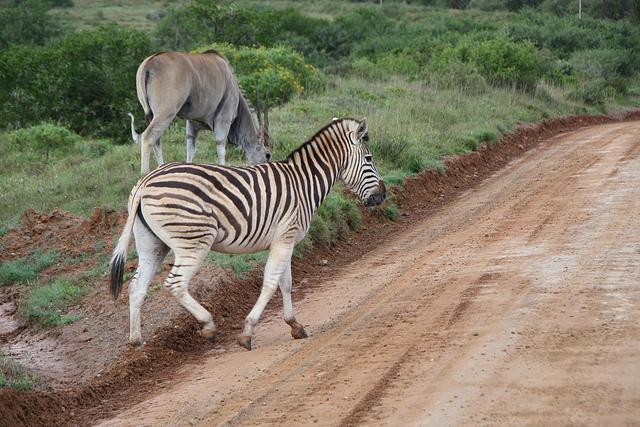What is the zebra on the left about to step into?
Indicate the correct response and explain using: 'Answer: answer
Rationale: rationale.'
Options: Grass, road, water, hay. Answer: road.
Rationale: The zebra is going to the road. 